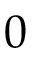<formula> <loc_0><loc_0><loc_500><loc_500>0</formula> 